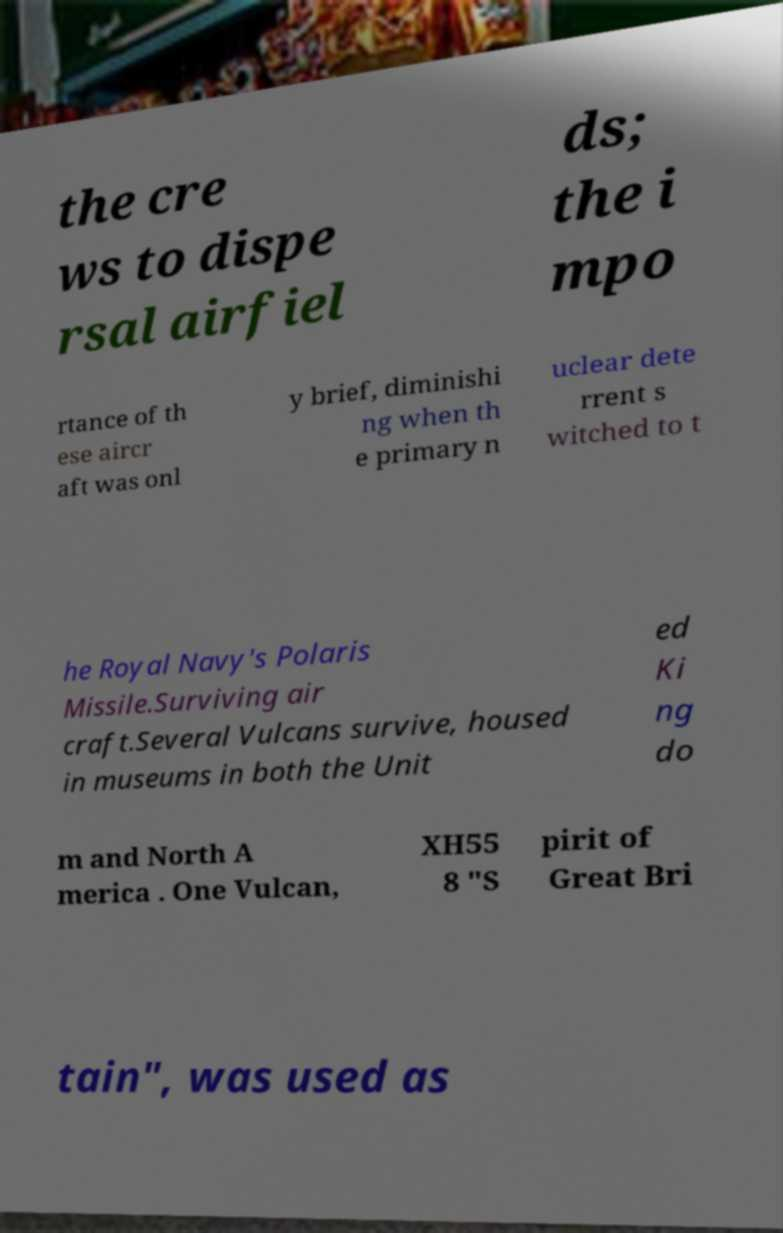I need the written content from this picture converted into text. Can you do that? the cre ws to dispe rsal airfiel ds; the i mpo rtance of th ese aircr aft was onl y brief, diminishi ng when th e primary n uclear dete rrent s witched to t he Royal Navy's Polaris Missile.Surviving air craft.Several Vulcans survive, housed in museums in both the Unit ed Ki ng do m and North A merica . One Vulcan, XH55 8 "S pirit of Great Bri tain", was used as 